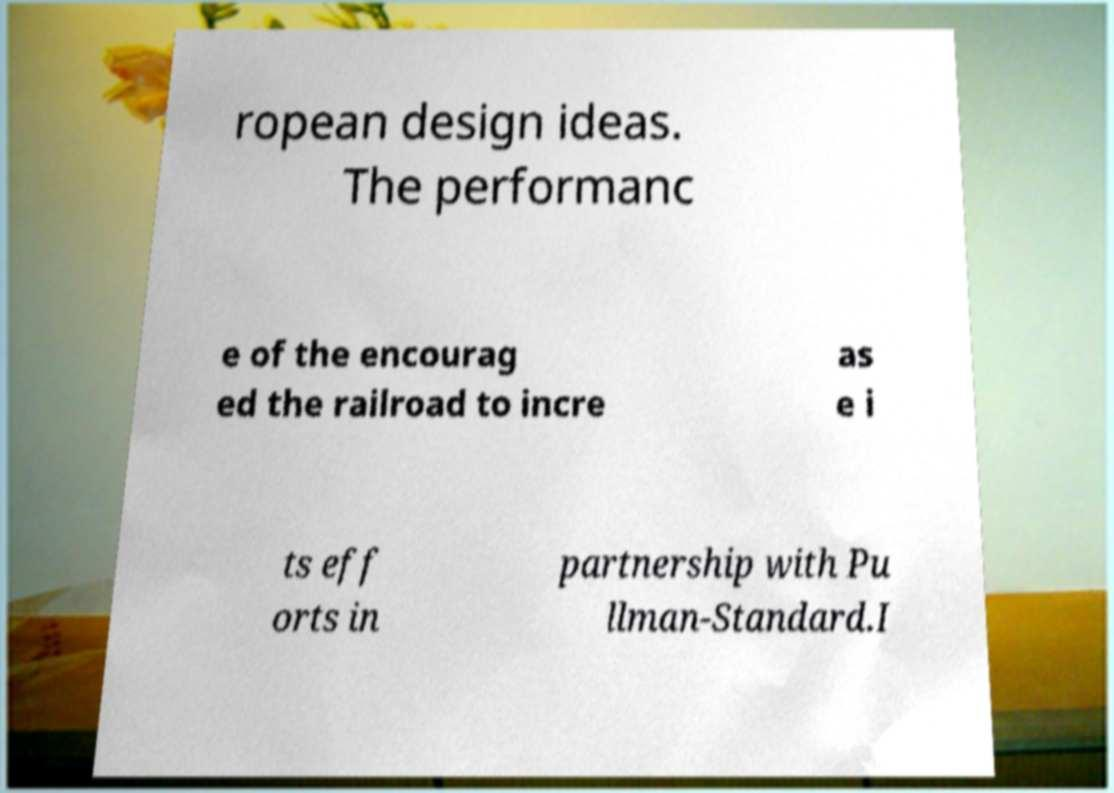Could you assist in decoding the text presented in this image and type it out clearly? ropean design ideas. The performanc e of the encourag ed the railroad to incre as e i ts eff orts in partnership with Pu llman-Standard.I 